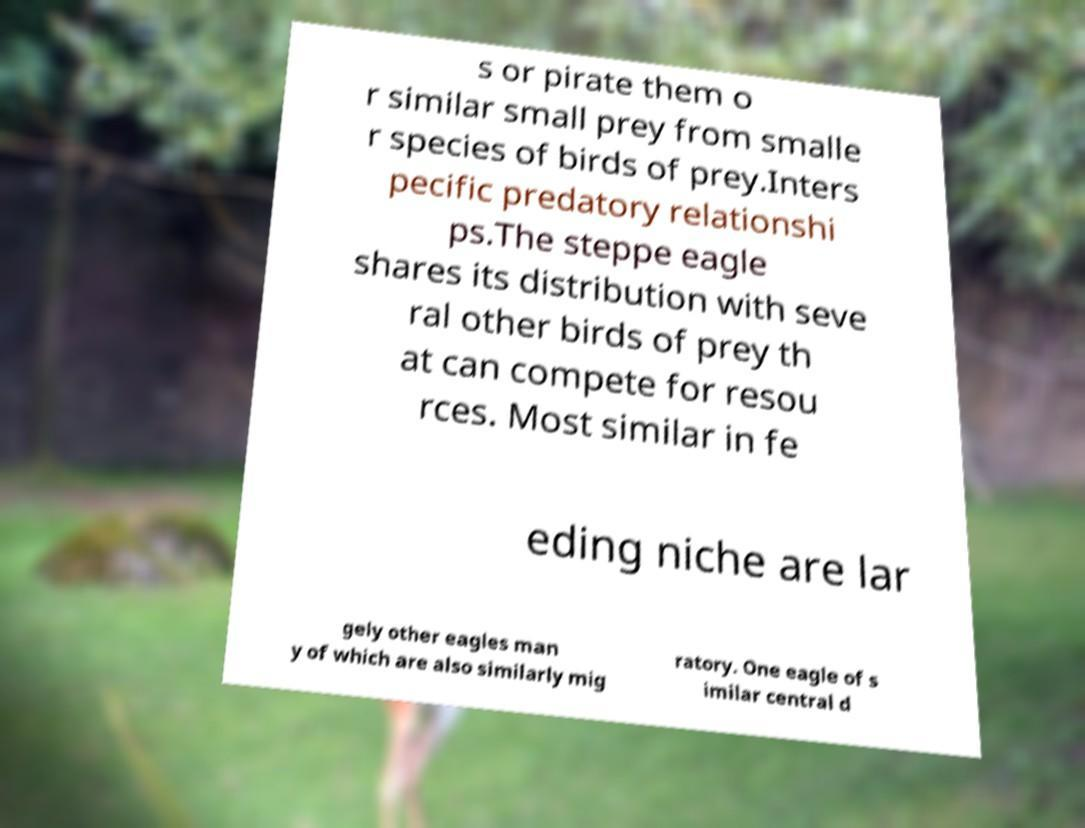Can you accurately transcribe the text from the provided image for me? s or pirate them o r similar small prey from smalle r species of birds of prey.Inters pecific predatory relationshi ps.The steppe eagle shares its distribution with seve ral other birds of prey th at can compete for resou rces. Most similar in fe eding niche are lar gely other eagles man y of which are also similarly mig ratory. One eagle of s imilar central d 